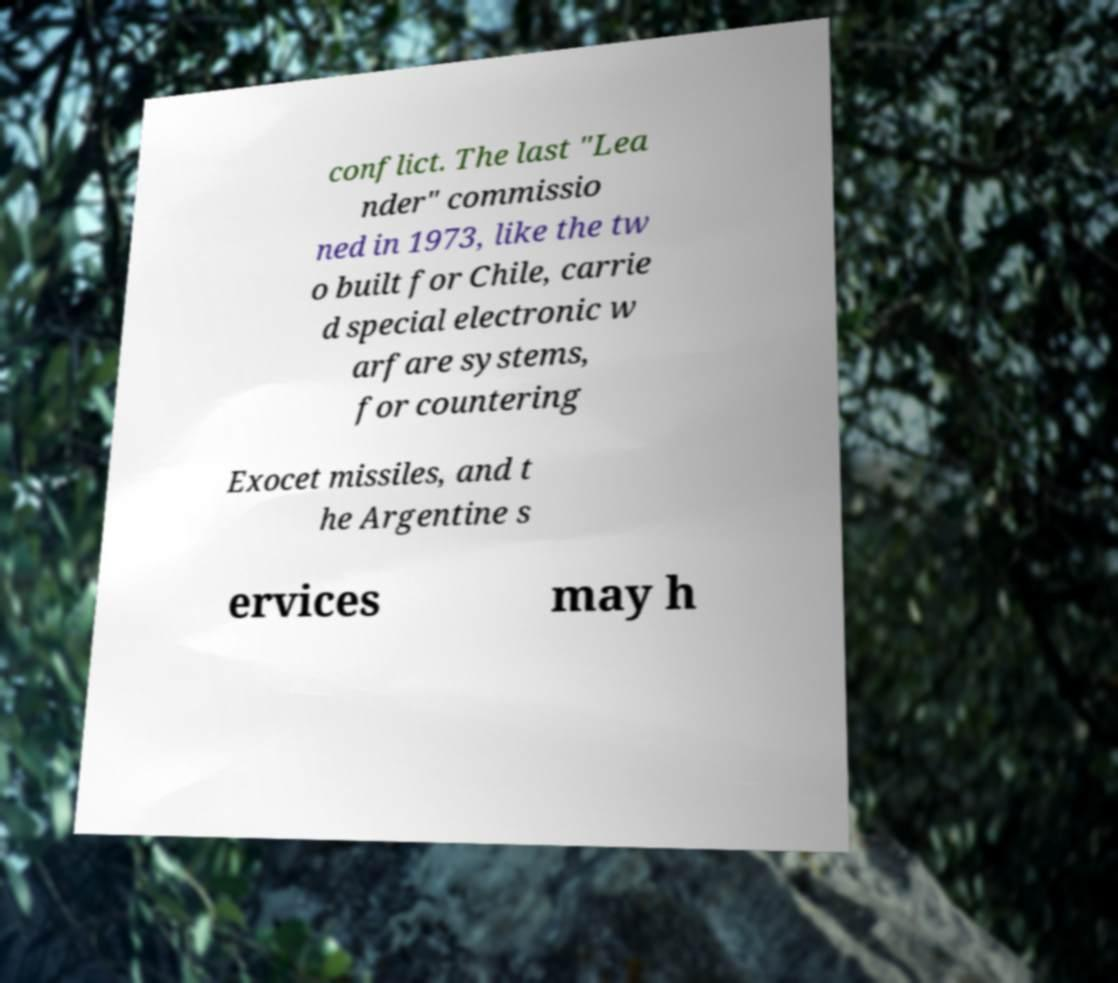Please read and relay the text visible in this image. What does it say? conflict. The last "Lea nder" commissio ned in 1973, like the tw o built for Chile, carrie d special electronic w arfare systems, for countering Exocet missiles, and t he Argentine s ervices may h 